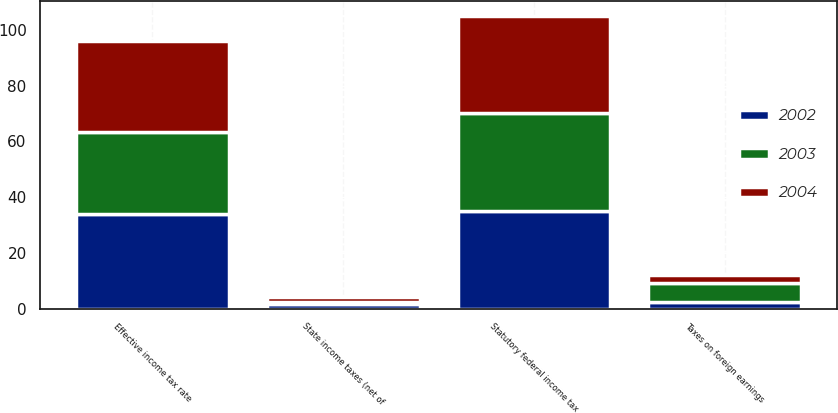Convert chart. <chart><loc_0><loc_0><loc_500><loc_500><stacked_bar_chart><ecel><fcel>Statutory federal income tax<fcel>State income taxes (net of<fcel>Taxes on foreign earnings<fcel>Effective income tax rate<nl><fcel>2003<fcel>35<fcel>1<fcel>6.6<fcel>29.5<nl><fcel>2004<fcel>35<fcel>1.5<fcel>3<fcel>32.6<nl><fcel>2002<fcel>35<fcel>1.5<fcel>2.5<fcel>34<nl></chart> 